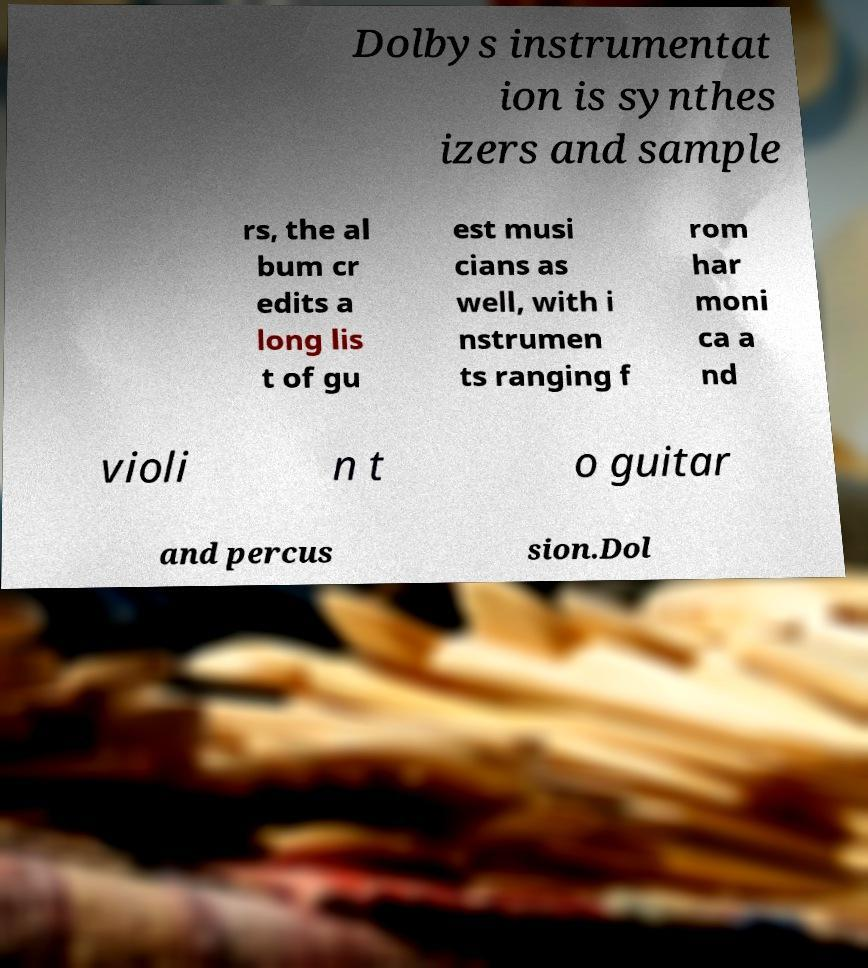Please identify and transcribe the text found in this image. Dolbys instrumentat ion is synthes izers and sample rs, the al bum cr edits a long lis t of gu est musi cians as well, with i nstrumen ts ranging f rom har moni ca a nd violi n t o guitar and percus sion.Dol 